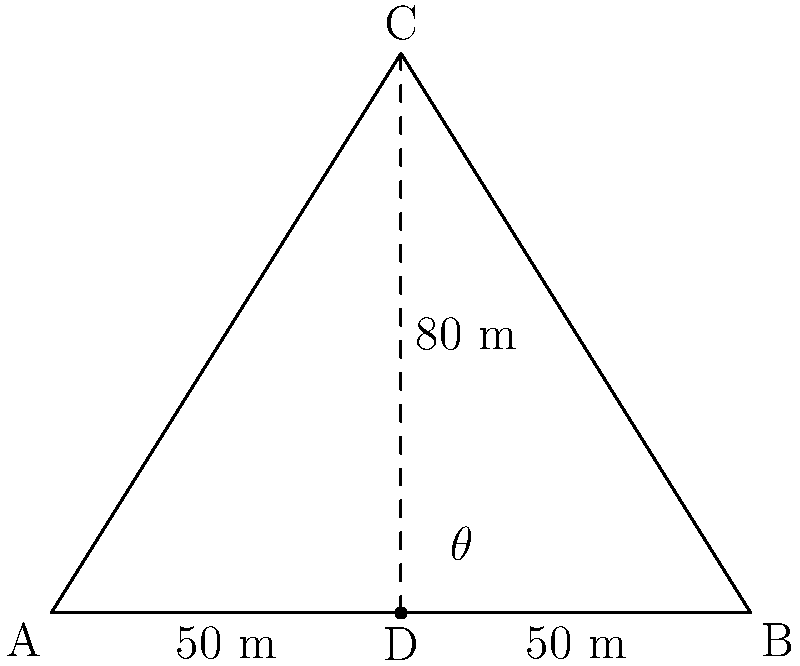Un pont ferroviaire doit être construit sur une rivière large de 100 mètres. Les ingénieurs proposent une structure en forme de triangle isocèle avec un support central. Si la hauteur du support central est de 80 mètres, quel est l'angle optimal $\theta$ (en degrés) entre le support et la base du pont pour assurer une distribution équilibrée du poids ? Pour résoudre ce problème, suivons ces étapes :

1) Le triangle formé par le pont et le support est isocèle. La base du triangle (la largeur de la rivière) est de 100 mètres, et la hauteur (le support central) est de 80 mètres.

2) Comme le triangle est isocèle, nous pouvons le diviser en deux triangles rectangles identiques. Concentrons-nous sur l'un de ces triangles rectangles.

3) Dans ce triangle rectangle :
   - La base est la moitié de la largeur du pont : 100/2 = 50 mètres
   - La hauteur est la même que le support central : 80 mètres

4) Pour trouver l'angle $\theta$, nous pouvons utiliser la fonction tangente :

   $$\tan(\theta) = \frac{\text{opposé}}{\text{adjacent}} = \frac{80}{50} = 1.6$$

5) Pour obtenir l'angle, nous devons calculer l'arc tangente (ou tan^(-1)) de ce rapport :

   $$\theta = \arctan(1.6)$$

6) En utilisant une calculatrice ou une fonction trigonométrique, nous obtenons :

   $$\theta \approx 57.995...^\circ$$

7) Arrondi à la première décimale : $\theta \approx 58.0^\circ$

Cet angle assure une distribution équilibrée du poids entre le support central et les extrémités du pont.
Answer: $58.0^\circ$ 